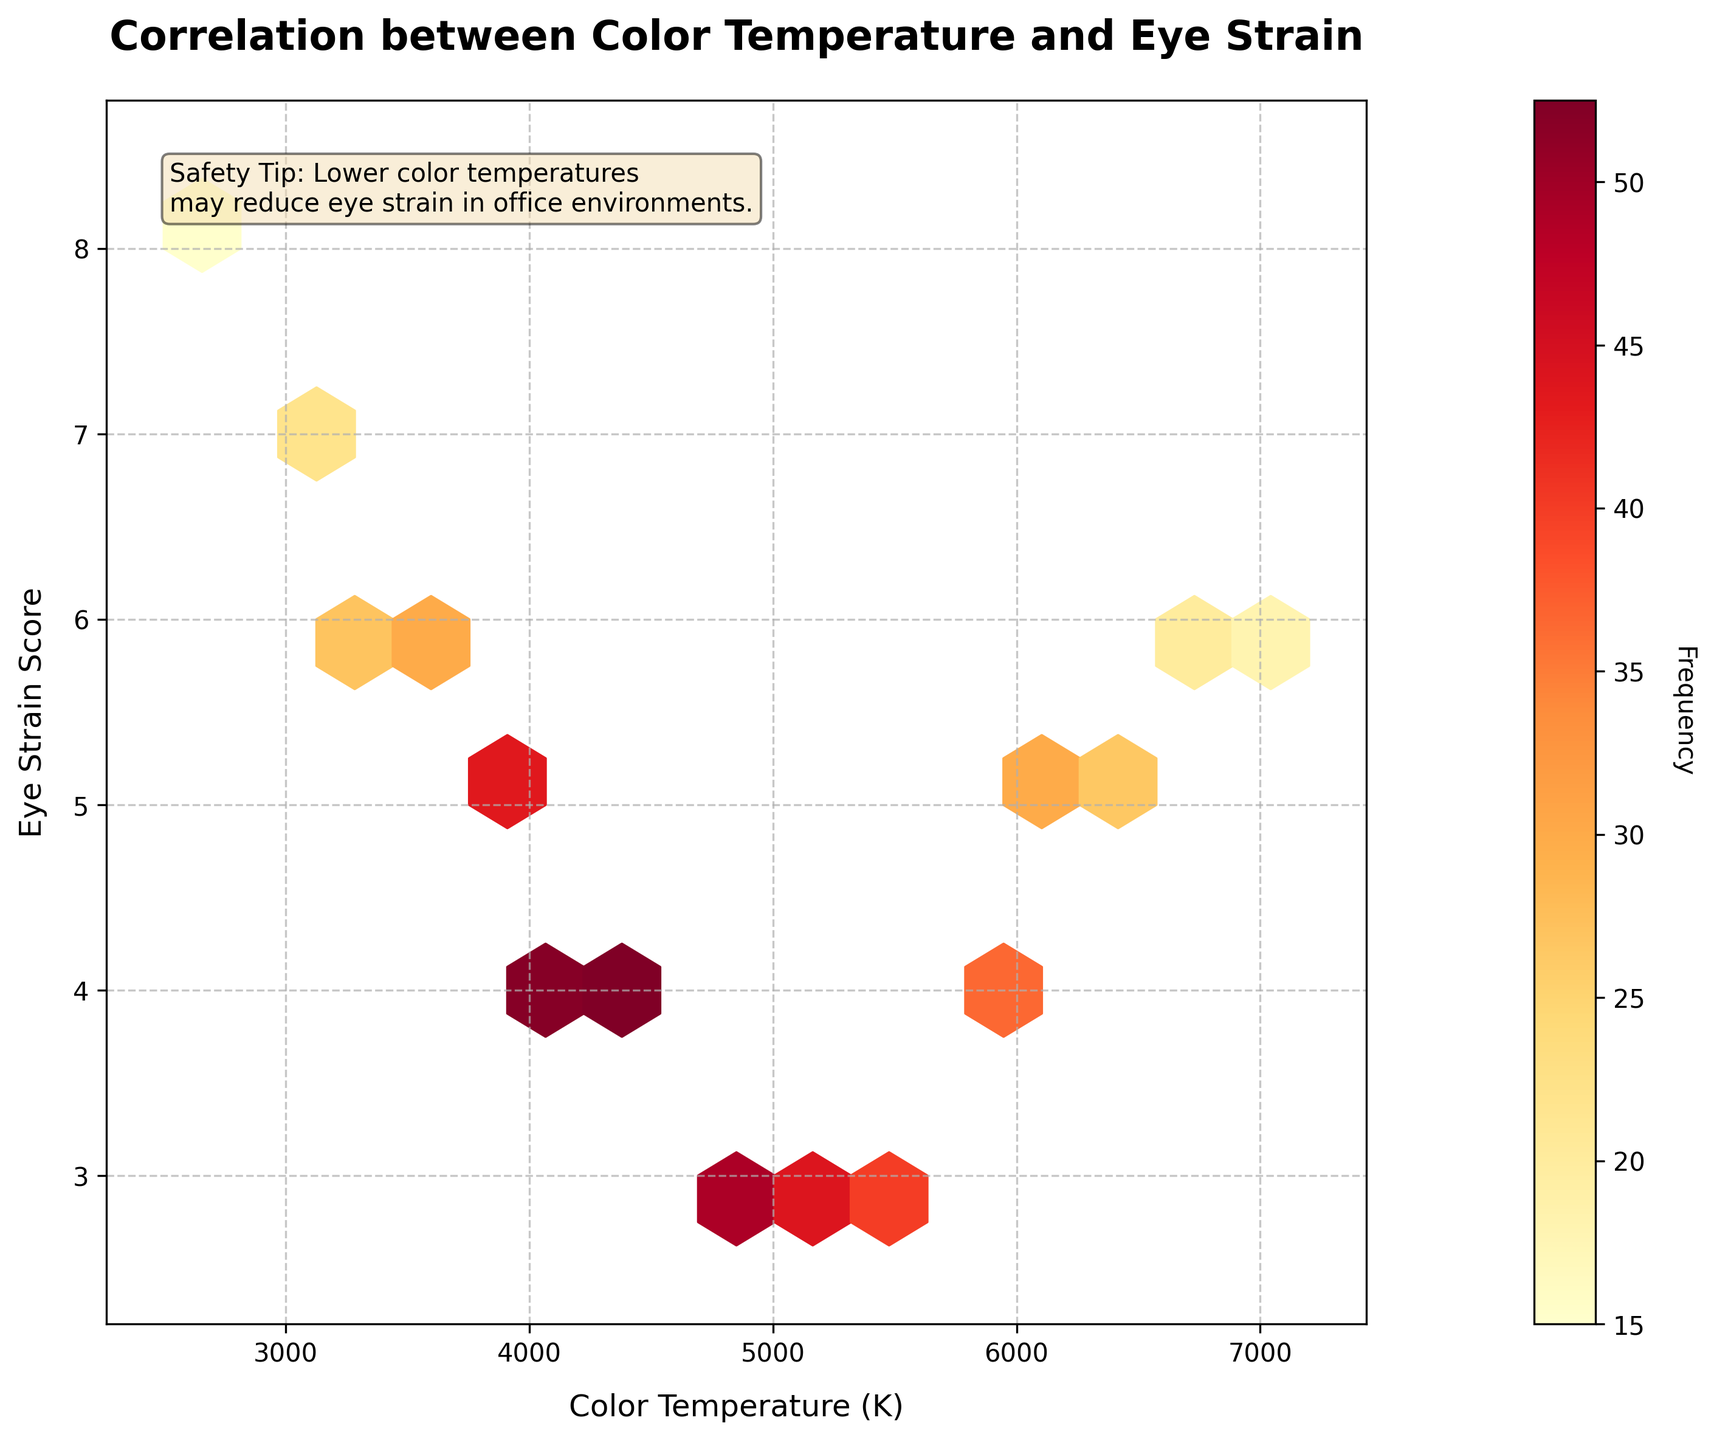What is the title of the figure? The title is usually located at the top of the figure. In this case, the title text is centered at the top.
Answer: Correlation between Color Temperature and Eye Strain What are the axis labels? Axis labels describe what each axis represents; these are found next to the respective axis.
Answer: Color Temperature (K) and Eye Strain Score What does the color bar represent? The color bar usually provides context for the gradient or color coding in the plot, indicating the values it represents. In this figure, it is labeled and described.
Answer: Frequency How many hexagons have the maximum frequency weight? Identify the darkest-colored hexagons since they represent the highest frequency. Count these.
Answer: One What is the range of eye strain scores observed in the plot? Look at the y-axis and note the minimum and maximum values within the plotted area.
Answer: 3 to 8 Which color temperature range has the higher frequency of eye strain scores between 4000 K and 5000 K? Compare the color intensity (darkness) of the hexagons within the given temperature range.
Answer: 4000 K In the range of 5000 K to 6000 K, which eye strain scores occur the most frequently? Identify the hexagons within the specified range and note the y-axis values corresponding to those with higher color intensity.
Answer: 3 and 4 Is there any clear relationship between color temperature and eye strain scores visible in the plot? Observe the overall trend indicated by the hexagon placements and their frequencies throughout the plot.
Answer: Yes, higher color temperatures generally correlate with lower eye strain scores Between 3000 K and 3500 K, which temperature has the higher eye strain score on average? Compare the hexagons within this range, focusing on their y-axis values and frequency.
Answer: 3000 K How does the frequency of eye strain scores with a color temperature of 7000 K compare to that with 6000 K? Compare the color intensity of the hexagons corresponding to these color temperatures.
Answer: Lower 